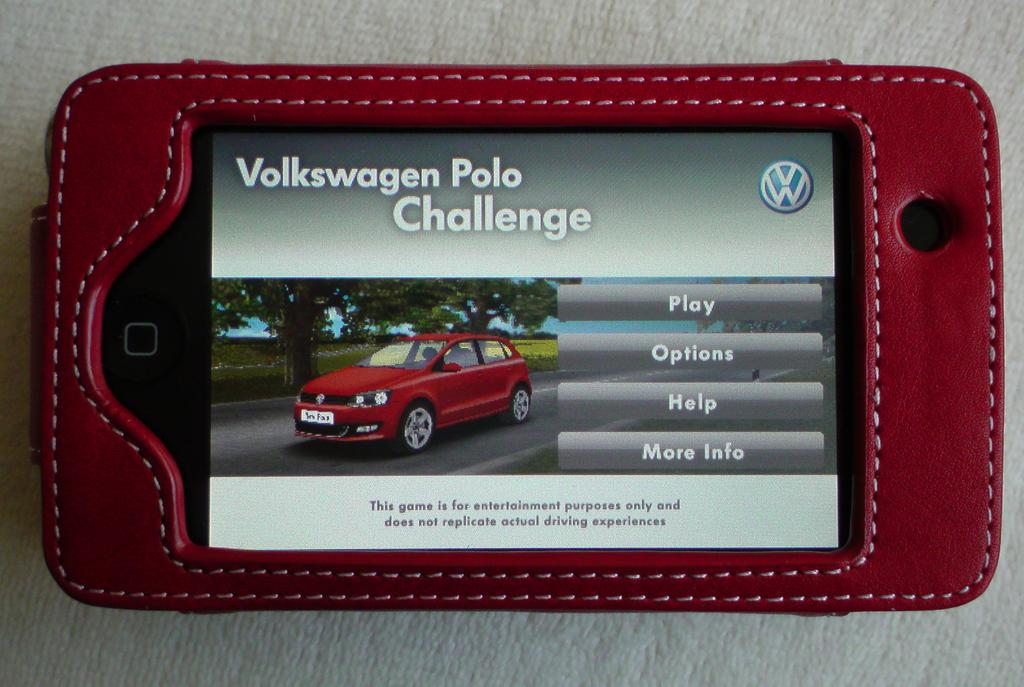What object is the main subject of the image? There is a mobile in the image. What feature does the mobile have? The mobile has a screen. How is the mobile covered in the image? The mobile is covered with a red color pouch. Where is the mobile placed in the image? The mobile is placed on a surface. What is the color of the background in the image? The background of the image is cream in color. How many houses can be seen in the image? There are no houses present in the image; it features a mobile covered with a red color pouch. What type of marble is used to decorate the mobile in the image? There is no marble present in the image; the mobile is covered with a red color pouch. 